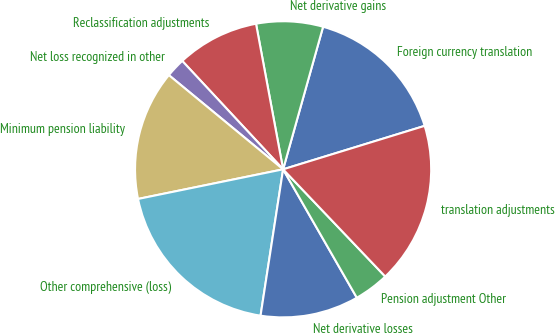<chart> <loc_0><loc_0><loc_500><loc_500><pie_chart><fcel>Foreign currency translation<fcel>Net derivative gains<fcel>Reclassification adjustments<fcel>Net loss recognized in other<fcel>Minimum pension liability<fcel>Other comprehensive (loss)<fcel>Net derivative losses<fcel>Pension adjustment Other<fcel>translation adjustments<nl><fcel>15.91%<fcel>7.28%<fcel>9.0%<fcel>2.1%<fcel>14.18%<fcel>19.36%<fcel>10.73%<fcel>3.82%<fcel>17.63%<nl></chart> 